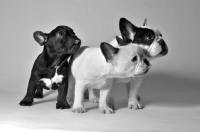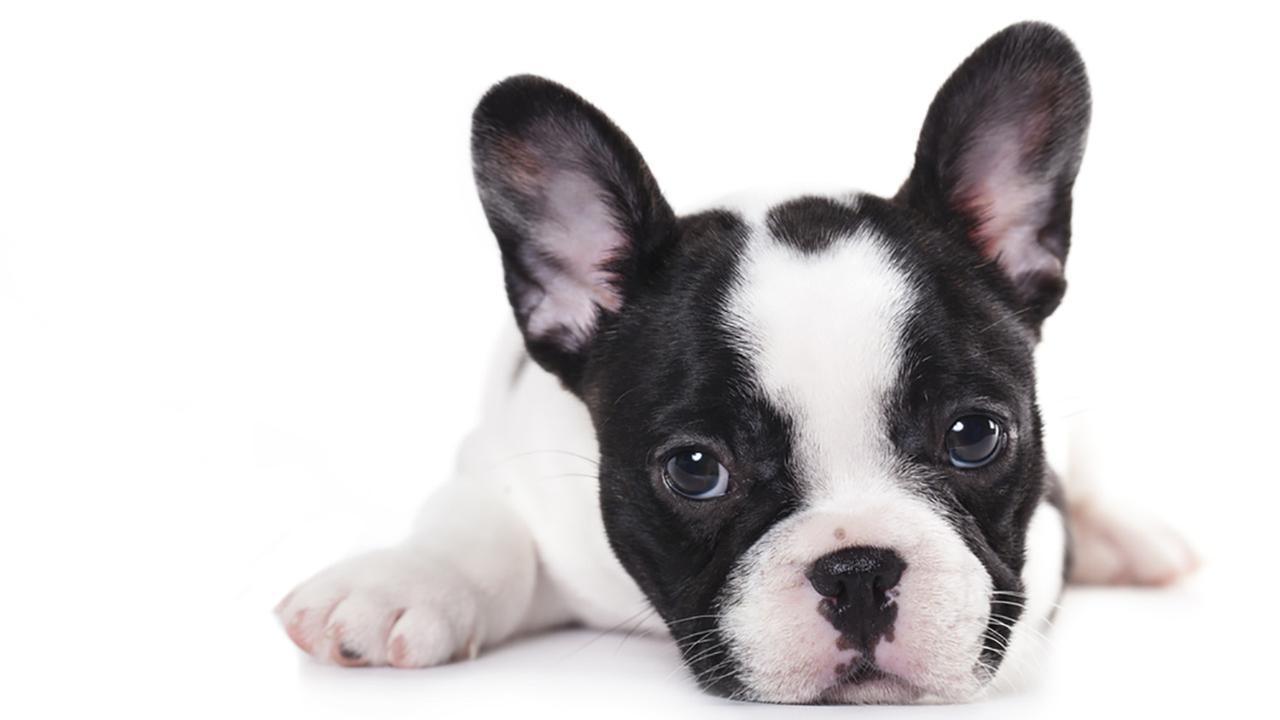The first image is the image on the left, the second image is the image on the right. For the images displayed, is the sentence "One of the images features three dogs with their front limbs draped over a horizontal edge." factually correct? Answer yes or no. No. The first image is the image on the left, the second image is the image on the right. Analyze the images presented: Is the assertion "Each image shows a horizontal row of three flat-faced dogs, and the right image shows the dogs leaning on a white ledge." valid? Answer yes or no. No. 